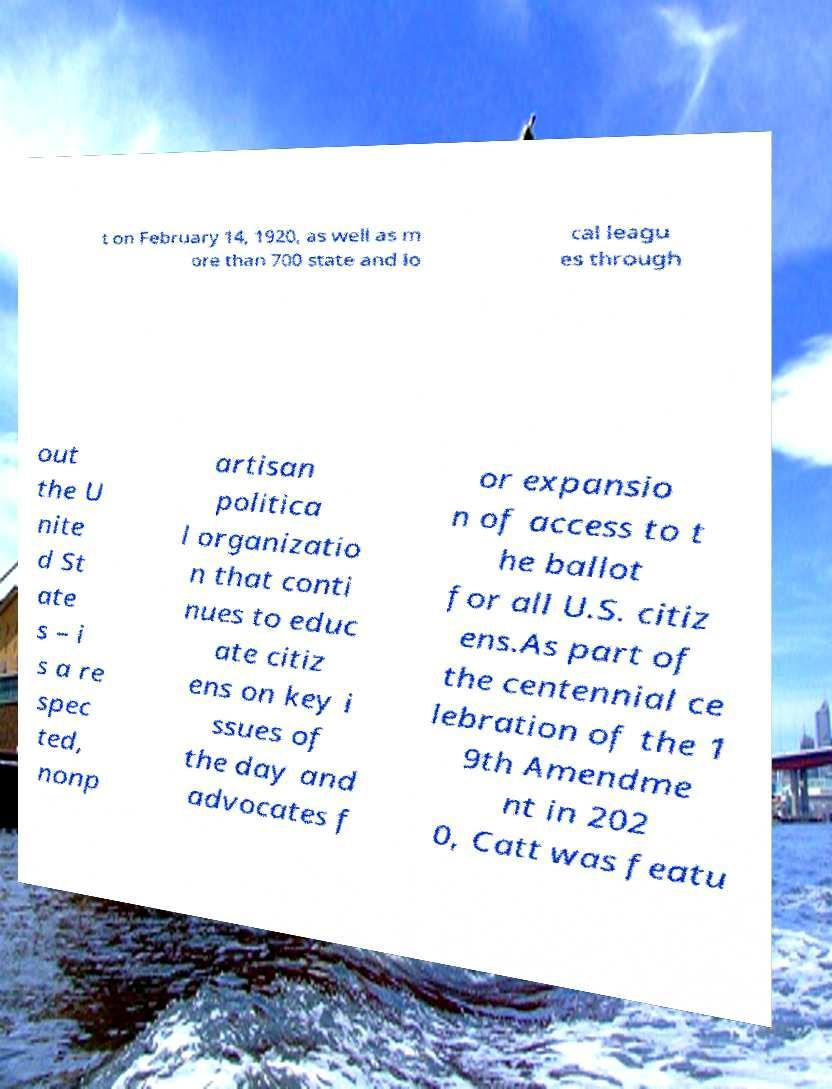For documentation purposes, I need the text within this image transcribed. Could you provide that? t on February 14, 1920, as well as m ore than 700 state and lo cal leagu es through out the U nite d St ate s – i s a re spec ted, nonp artisan politica l organizatio n that conti nues to educ ate citiz ens on key i ssues of the day and advocates f or expansio n of access to t he ballot for all U.S. citiz ens.As part of the centennial ce lebration of the 1 9th Amendme nt in 202 0, Catt was featu 